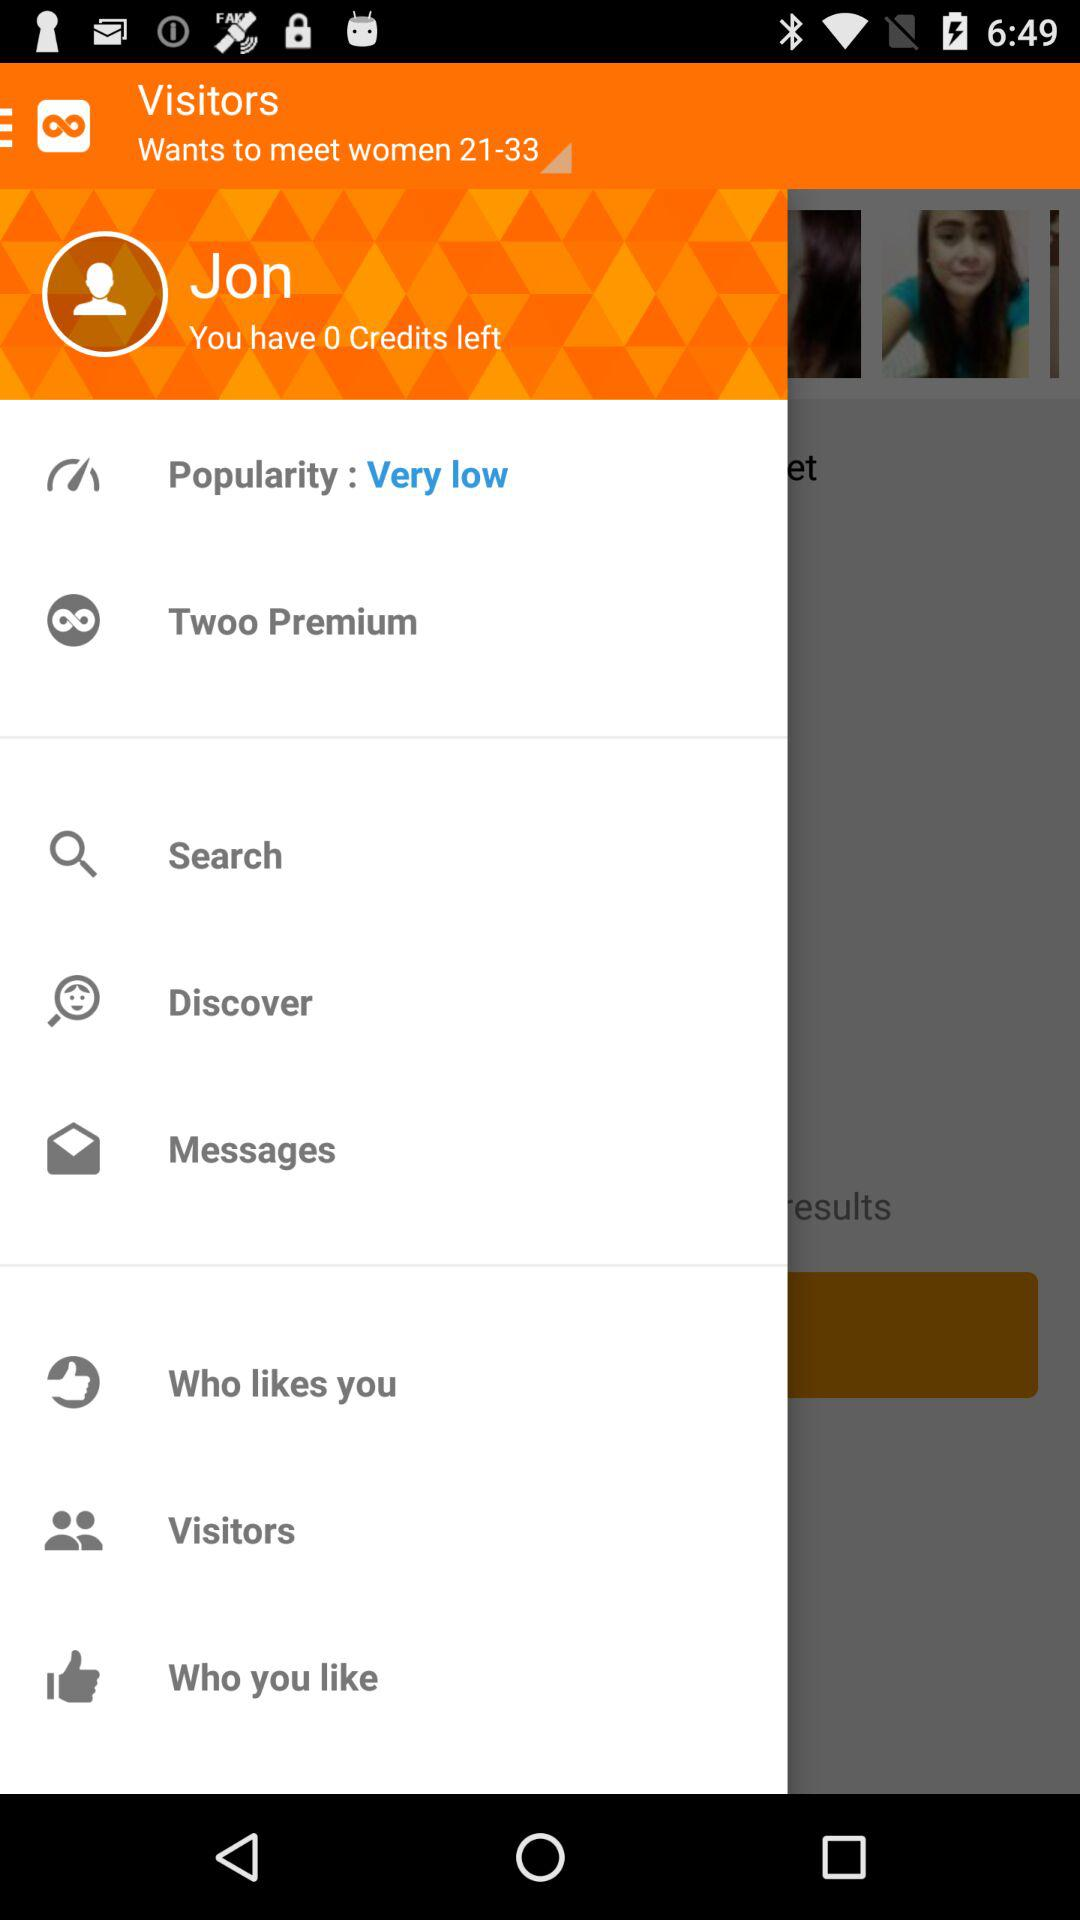What is the "Popularity"? The "Popularity" is very low. 